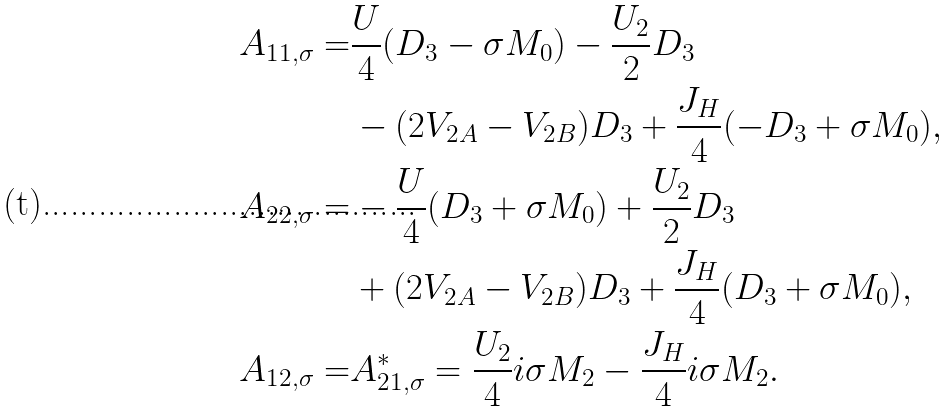<formula> <loc_0><loc_0><loc_500><loc_500>A _ { 1 1 , \sigma } = & \frac { U } { 4 } ( D _ { 3 } - \sigma M _ { 0 } ) - \frac { U _ { 2 } } { 2 } D _ { 3 } \\ & - ( 2 V _ { 2 A } - V _ { 2 B } ) D _ { 3 } + \frac { J _ { H } } { 4 } ( - D _ { 3 } + \sigma M _ { 0 } ) , \\ A _ { 2 2 , \sigma } = & - \frac { U } { 4 } ( D _ { 3 } + \sigma M _ { 0 } ) + \frac { U _ { 2 } } { 2 } D _ { 3 } \\ & + ( 2 V _ { 2 A } - V _ { 2 B } ) D _ { 3 } + \frac { J _ { H } } { 4 } ( D _ { 3 } + \sigma M _ { 0 } ) , \\ A _ { 1 2 , \sigma } = & A ^ { * } _ { 2 1 , \sigma } = \frac { U _ { 2 } } { 4 } i \sigma M _ { 2 } - \frac { J _ { H } } { 4 } i \sigma M _ { 2 } .</formula> 